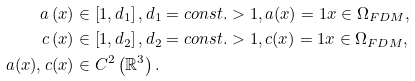<formula> <loc_0><loc_0><loc_500><loc_500>a \left ( x \right ) & \in \left [ 1 , d _ { 1 } \right ] , d _ { 1 } = c o n s t . > 1 , a ( x ) = 1 x \in \Omega _ { F D M } , \\ c \left ( x \right ) & \in \left [ 1 , d _ { 2 } \right ] , d _ { 2 } = c o n s t . > 1 , c ( x ) = 1 x \in \Omega _ { F D M } , \\ a ( x ) , c ( x ) & \in C ^ { 2 } \left ( \mathbb { R } ^ { 3 } \right ) .</formula> 